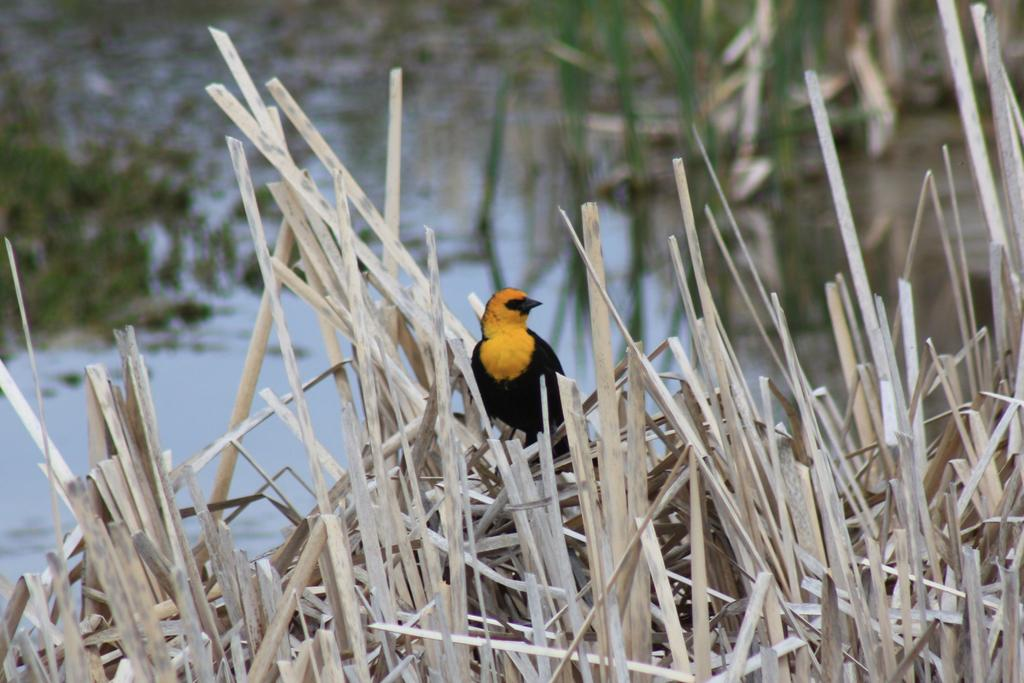What type of animal is in the image? There is a bird in the image. What is the bird standing on? The bird is standing on wooden sticks. Where are the wooden sticks located in the image? The wooden sticks are in the center of the image. What type of team can be seen playing in the image? There is no team present in the image; it features a bird standing on wooden sticks. How many bees are visible in the image? There are no bees present in the image. 